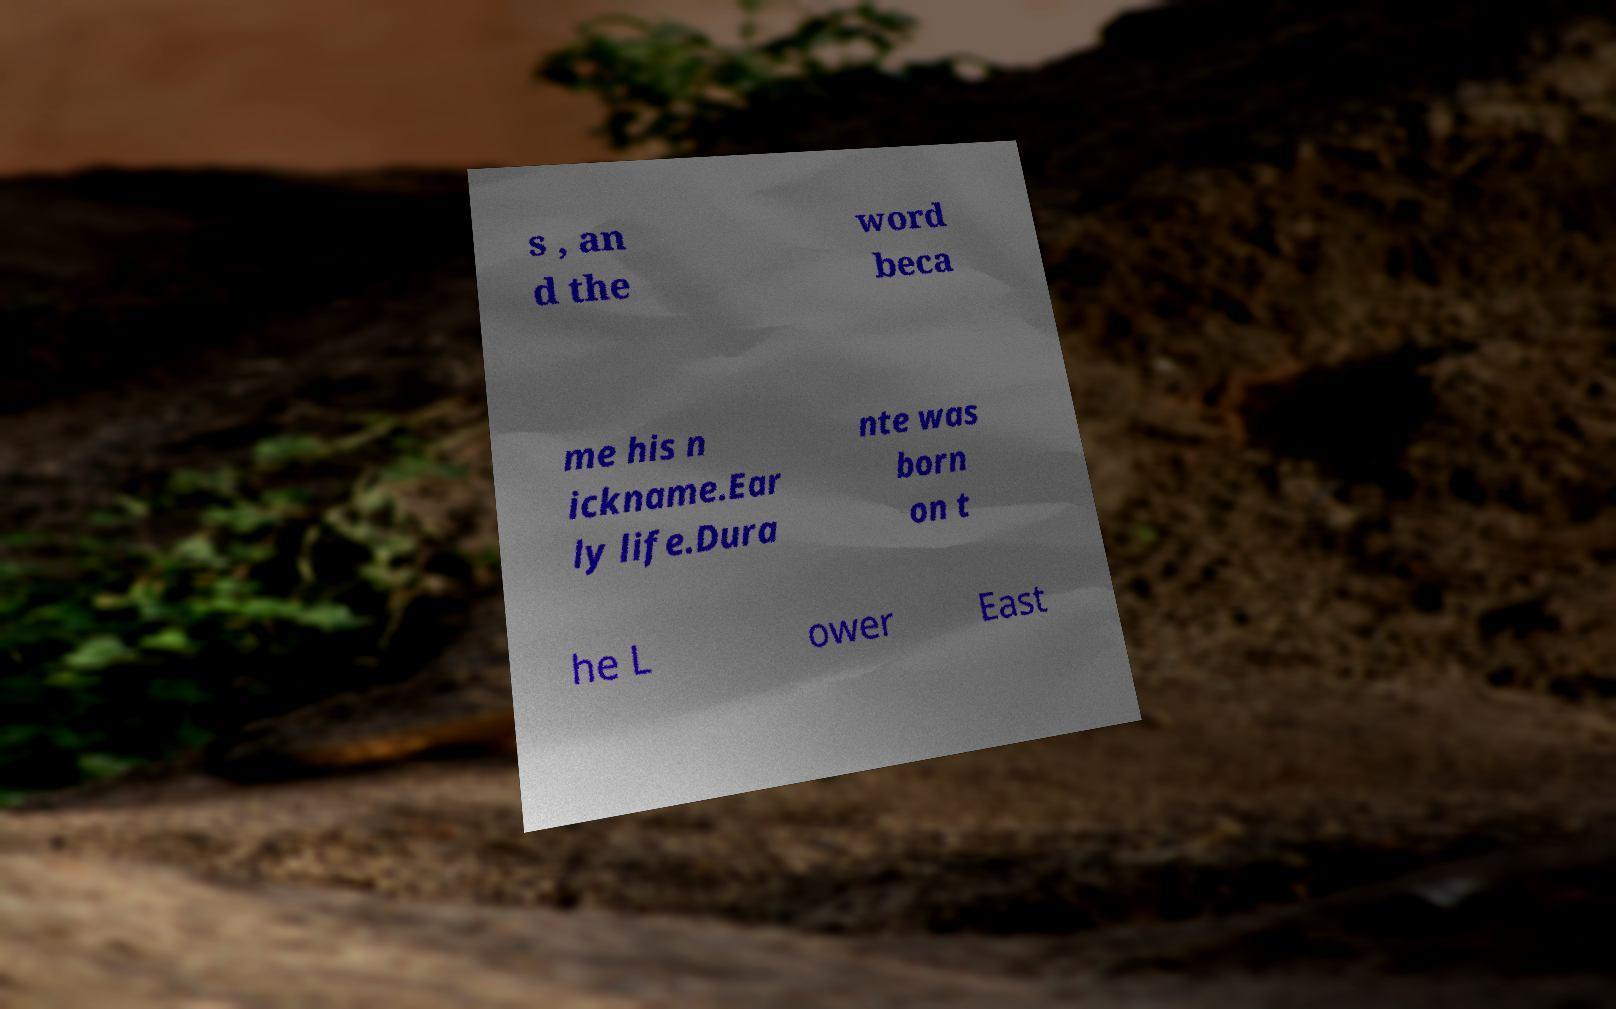For documentation purposes, I need the text within this image transcribed. Could you provide that? s , an d the word beca me his n ickname.Ear ly life.Dura nte was born on t he L ower East 